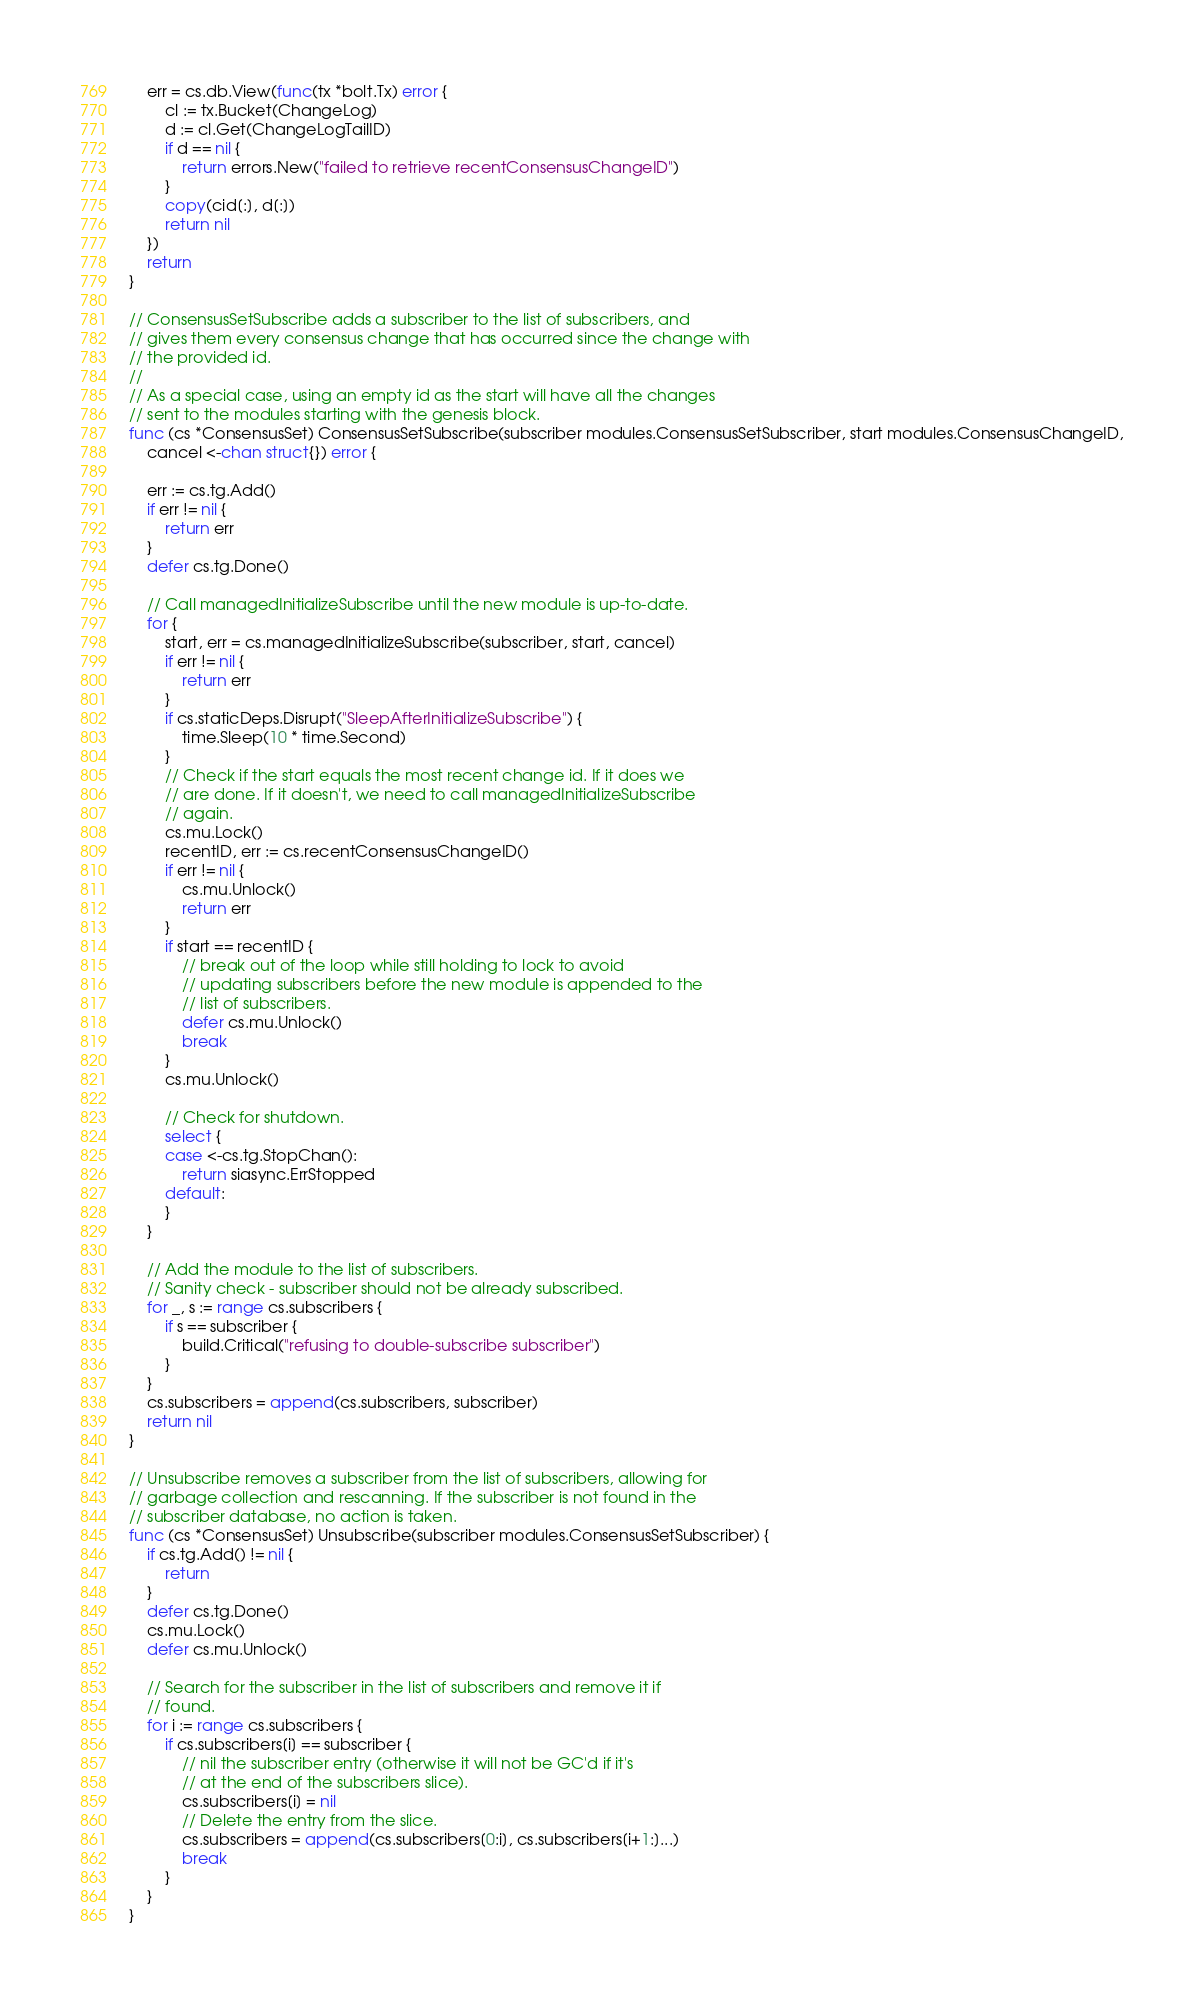<code> <loc_0><loc_0><loc_500><loc_500><_Go_>	err = cs.db.View(func(tx *bolt.Tx) error {
		cl := tx.Bucket(ChangeLog)
		d := cl.Get(ChangeLogTailID)
		if d == nil {
			return errors.New("failed to retrieve recentConsensusChangeID")
		}
		copy(cid[:], d[:])
		return nil
	})
	return
}

// ConsensusSetSubscribe adds a subscriber to the list of subscribers, and
// gives them every consensus change that has occurred since the change with
// the provided id.
//
// As a special case, using an empty id as the start will have all the changes
// sent to the modules starting with the genesis block.
func (cs *ConsensusSet) ConsensusSetSubscribe(subscriber modules.ConsensusSetSubscriber, start modules.ConsensusChangeID,
	cancel <-chan struct{}) error {

	err := cs.tg.Add()
	if err != nil {
		return err
	}
	defer cs.tg.Done()

	// Call managedInitializeSubscribe until the new module is up-to-date.
	for {
		start, err = cs.managedInitializeSubscribe(subscriber, start, cancel)
		if err != nil {
			return err
		}
		if cs.staticDeps.Disrupt("SleepAfterInitializeSubscribe") {
			time.Sleep(10 * time.Second)
		}
		// Check if the start equals the most recent change id. If it does we
		// are done. If it doesn't, we need to call managedInitializeSubscribe
		// again.
		cs.mu.Lock()
		recentID, err := cs.recentConsensusChangeID()
		if err != nil {
			cs.mu.Unlock()
			return err
		}
		if start == recentID {
			// break out of the loop while still holding to lock to avoid
			// updating subscribers before the new module is appended to the
			// list of subscribers.
			defer cs.mu.Unlock()
			break
		}
		cs.mu.Unlock()

		// Check for shutdown.
		select {
		case <-cs.tg.StopChan():
			return siasync.ErrStopped
		default:
		}
	}

	// Add the module to the list of subscribers.
	// Sanity check - subscriber should not be already subscribed.
	for _, s := range cs.subscribers {
		if s == subscriber {
			build.Critical("refusing to double-subscribe subscriber")
		}
	}
	cs.subscribers = append(cs.subscribers, subscriber)
	return nil
}

// Unsubscribe removes a subscriber from the list of subscribers, allowing for
// garbage collection and rescanning. If the subscriber is not found in the
// subscriber database, no action is taken.
func (cs *ConsensusSet) Unsubscribe(subscriber modules.ConsensusSetSubscriber) {
	if cs.tg.Add() != nil {
		return
	}
	defer cs.tg.Done()
	cs.mu.Lock()
	defer cs.mu.Unlock()

	// Search for the subscriber in the list of subscribers and remove it if
	// found.
	for i := range cs.subscribers {
		if cs.subscribers[i] == subscriber {
			// nil the subscriber entry (otherwise it will not be GC'd if it's
			// at the end of the subscribers slice).
			cs.subscribers[i] = nil
			// Delete the entry from the slice.
			cs.subscribers = append(cs.subscribers[0:i], cs.subscribers[i+1:]...)
			break
		}
	}
}
</code> 